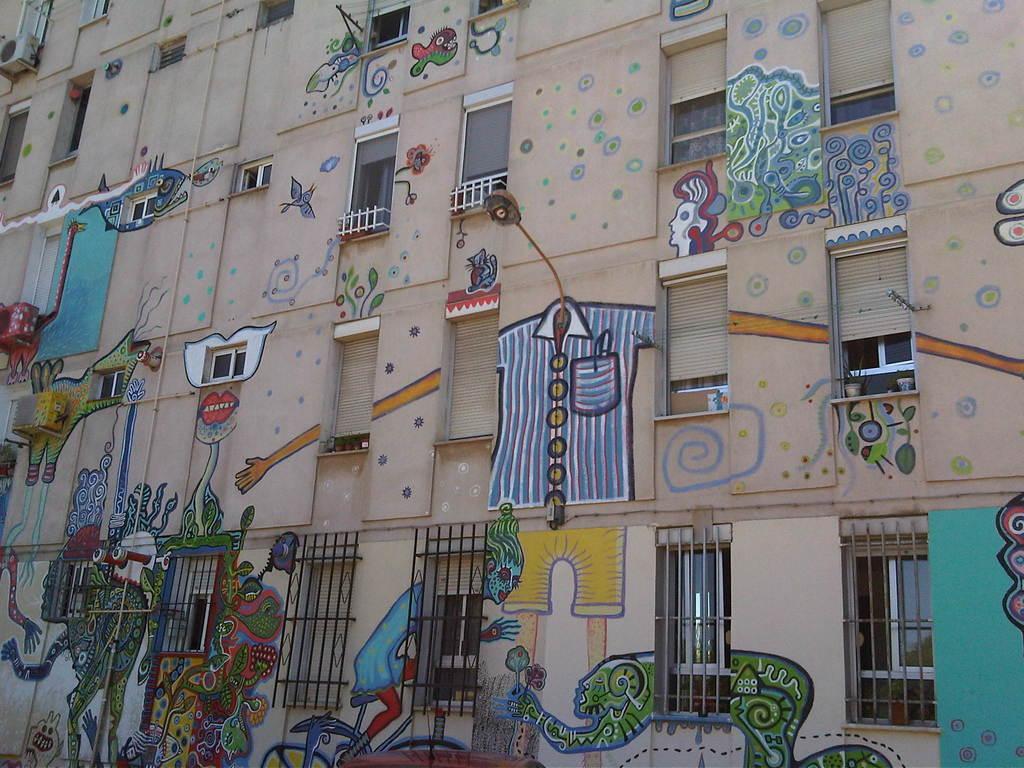Describe this image in one or two sentences. In this picture we can see a building. There is a painting and a few windows on this building. 